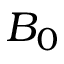<formula> <loc_0><loc_0><loc_500><loc_500>B _ { 0 }</formula> 